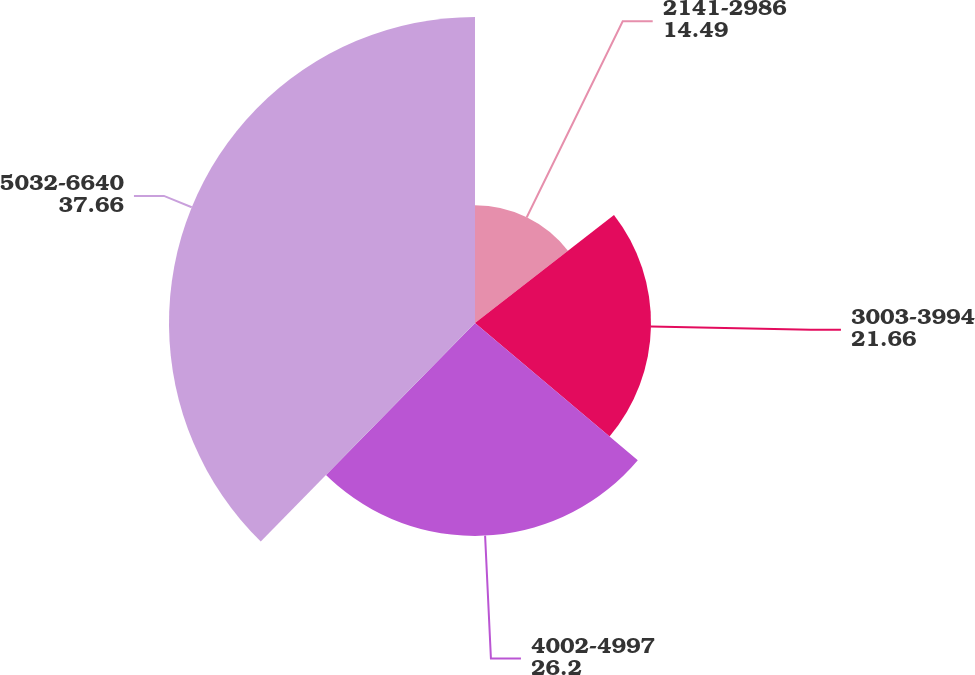<chart> <loc_0><loc_0><loc_500><loc_500><pie_chart><fcel>2141-2986<fcel>3003-3994<fcel>4002-4997<fcel>5032-6640<nl><fcel>14.49%<fcel>21.66%<fcel>26.2%<fcel>37.66%<nl></chart> 